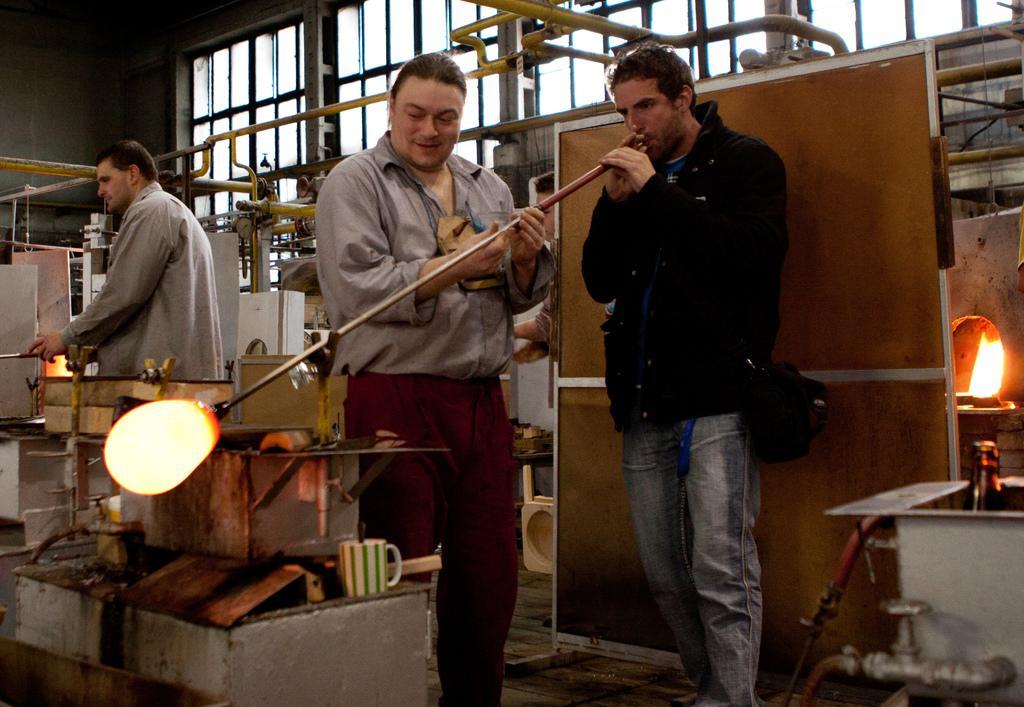How would you summarize this image in a sentence or two? In this picture I can see there are three persons standing and they are wearing coats and the person standing here is holding a rod and there is something attached to the other end and there is some equipment here and there is a window here in the backdrop. 